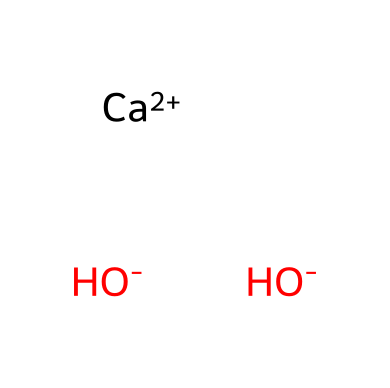What is the chemical formula of calcium hydroxide? The SMILES representation includes 'Ca' for calcium and 'OH' for hydroxide. The chemical formula combines these as Ca(OH)2.
Answer: Ca(OH)2 How many hydroxide ions are present in the chemical? The SMILES shows two occurrences of 'OH-', indicating there are two hydroxide ions.
Answer: 2 What charge does calcium have in this compound? The notation '[Ca+2]' indicates that calcium has a +2 charge.
Answer: +2 What type of compound is calcium hydroxide? Since it contains hydroxide ions and is made up of a metal (calcium) and hydroxide, it classifies as a base.
Answer: base What does the presence of calcium in this chemical indicate about its properties? Calcium, being a metal with a +2 charge, suggests that the compound can easily dissociate in water, contributing to its basic properties.
Answer: basic properties How many atoms are present in the compound? The compound contains 1 calcium atom and 2 oxygen atoms from hydroxide, along with 2 hydrogen atoms, totaling 5 atoms.
Answer: 5 